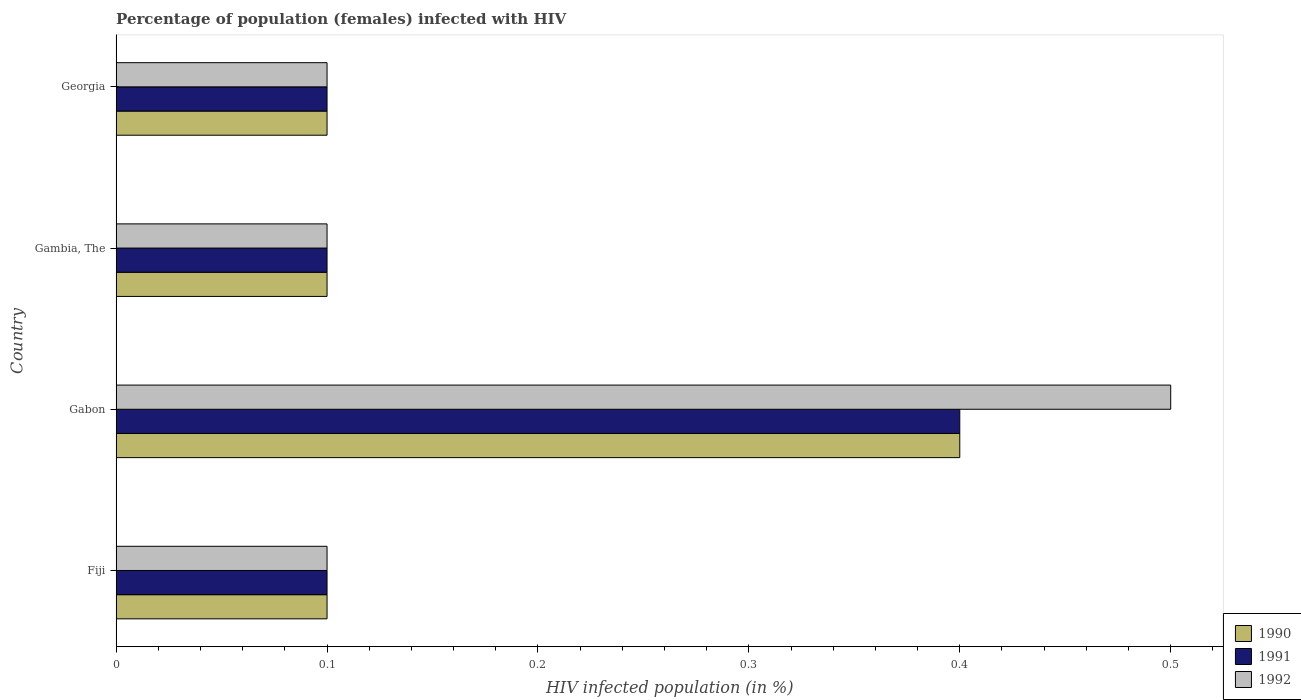How many different coloured bars are there?
Provide a succinct answer. 3. How many groups of bars are there?
Your answer should be compact. 4. Are the number of bars on each tick of the Y-axis equal?
Provide a short and direct response. Yes. How many bars are there on the 2nd tick from the top?
Provide a short and direct response. 3. How many bars are there on the 1st tick from the bottom?
Make the answer very short. 3. What is the label of the 3rd group of bars from the top?
Your answer should be very brief. Gabon. In how many cases, is the number of bars for a given country not equal to the number of legend labels?
Offer a very short reply. 0. What is the percentage of HIV infected female population in 1992 in Georgia?
Offer a terse response. 0.1. Across all countries, what is the maximum percentage of HIV infected female population in 1990?
Keep it short and to the point. 0.4. In which country was the percentage of HIV infected female population in 1990 maximum?
Provide a short and direct response. Gabon. In which country was the percentage of HIV infected female population in 1992 minimum?
Your answer should be very brief. Fiji. What is the total percentage of HIV infected female population in 1990 in the graph?
Provide a succinct answer. 0.7. What is the difference between the percentage of HIV infected female population in 1992 in Gambia, The and the percentage of HIV infected female population in 1990 in Georgia?
Provide a succinct answer. 0. What is the average percentage of HIV infected female population in 1990 per country?
Keep it short and to the point. 0.17. What is the difference between the percentage of HIV infected female population in 1992 and percentage of HIV infected female population in 1990 in Gabon?
Offer a terse response. 0.1. In how many countries, is the percentage of HIV infected female population in 1992 greater than 0.42000000000000004 %?
Provide a short and direct response. 1. What is the difference between the highest and the second highest percentage of HIV infected female population in 1990?
Keep it short and to the point. 0.3. In how many countries, is the percentage of HIV infected female population in 1990 greater than the average percentage of HIV infected female population in 1990 taken over all countries?
Provide a succinct answer. 1. Is the sum of the percentage of HIV infected female population in 1990 in Fiji and Gabon greater than the maximum percentage of HIV infected female population in 1992 across all countries?
Keep it short and to the point. No. What does the 1st bar from the bottom in Gambia, The represents?
Keep it short and to the point. 1990. Is it the case that in every country, the sum of the percentage of HIV infected female population in 1991 and percentage of HIV infected female population in 1992 is greater than the percentage of HIV infected female population in 1990?
Provide a short and direct response. Yes. Are all the bars in the graph horizontal?
Offer a very short reply. Yes. How many countries are there in the graph?
Offer a very short reply. 4. Does the graph contain any zero values?
Provide a succinct answer. No. How many legend labels are there?
Make the answer very short. 3. How are the legend labels stacked?
Your response must be concise. Vertical. What is the title of the graph?
Your response must be concise. Percentage of population (females) infected with HIV. What is the label or title of the X-axis?
Make the answer very short. HIV infected population (in %). What is the label or title of the Y-axis?
Give a very brief answer. Country. What is the HIV infected population (in %) in 1990 in Fiji?
Your answer should be compact. 0.1. What is the HIV infected population (in %) of 1990 in Gabon?
Your answer should be compact. 0.4. What is the HIV infected population (in %) in 1991 in Gambia, The?
Your answer should be compact. 0.1. What is the HIV infected population (in %) in 1991 in Georgia?
Offer a terse response. 0.1. What is the HIV infected population (in %) in 1992 in Georgia?
Your answer should be compact. 0.1. Across all countries, what is the maximum HIV infected population (in %) of 1992?
Offer a very short reply. 0.5. Across all countries, what is the minimum HIV infected population (in %) of 1990?
Your answer should be very brief. 0.1. Across all countries, what is the minimum HIV infected population (in %) in 1991?
Your response must be concise. 0.1. What is the total HIV infected population (in %) of 1990 in the graph?
Offer a very short reply. 0.7. What is the total HIV infected population (in %) in 1991 in the graph?
Your answer should be very brief. 0.7. What is the total HIV infected population (in %) in 1992 in the graph?
Give a very brief answer. 0.8. What is the difference between the HIV infected population (in %) of 1990 in Fiji and that in Gambia, The?
Your response must be concise. 0. What is the difference between the HIV infected population (in %) in 1990 in Fiji and that in Georgia?
Your answer should be compact. 0. What is the difference between the HIV infected population (in %) in 1990 in Gabon and that in Gambia, The?
Make the answer very short. 0.3. What is the difference between the HIV infected population (in %) of 1991 in Gabon and that in Gambia, The?
Keep it short and to the point. 0.3. What is the difference between the HIV infected population (in %) of 1992 in Gabon and that in Gambia, The?
Offer a terse response. 0.4. What is the difference between the HIV infected population (in %) of 1990 in Gambia, The and that in Georgia?
Offer a very short reply. 0. What is the difference between the HIV infected population (in %) in 1992 in Gambia, The and that in Georgia?
Offer a very short reply. 0. What is the difference between the HIV infected population (in %) in 1990 in Fiji and the HIV infected population (in %) in 1991 in Gabon?
Your answer should be compact. -0.3. What is the difference between the HIV infected population (in %) of 1990 in Fiji and the HIV infected population (in %) of 1991 in Gambia, The?
Offer a terse response. 0. What is the difference between the HIV infected population (in %) of 1990 in Fiji and the HIV infected population (in %) of 1991 in Georgia?
Your answer should be compact. 0. What is the difference between the HIV infected population (in %) of 1990 in Fiji and the HIV infected population (in %) of 1992 in Georgia?
Your answer should be very brief. 0. What is the difference between the HIV infected population (in %) of 1991 in Fiji and the HIV infected population (in %) of 1992 in Georgia?
Your answer should be compact. 0. What is the difference between the HIV infected population (in %) in 1990 in Gabon and the HIV infected population (in %) in 1991 in Gambia, The?
Provide a succinct answer. 0.3. What is the difference between the HIV infected population (in %) of 1990 in Gabon and the HIV infected population (in %) of 1992 in Gambia, The?
Your answer should be compact. 0.3. What is the difference between the HIV infected population (in %) of 1990 in Gabon and the HIV infected population (in %) of 1991 in Georgia?
Provide a short and direct response. 0.3. What is the difference between the HIV infected population (in %) of 1990 in Gabon and the HIV infected population (in %) of 1992 in Georgia?
Ensure brevity in your answer.  0.3. What is the difference between the HIV infected population (in %) of 1991 in Gabon and the HIV infected population (in %) of 1992 in Georgia?
Your response must be concise. 0.3. What is the difference between the HIV infected population (in %) of 1991 in Gambia, The and the HIV infected population (in %) of 1992 in Georgia?
Make the answer very short. 0. What is the average HIV infected population (in %) in 1990 per country?
Provide a succinct answer. 0.17. What is the average HIV infected population (in %) in 1991 per country?
Your response must be concise. 0.17. What is the average HIV infected population (in %) of 1992 per country?
Your answer should be very brief. 0.2. What is the difference between the HIV infected population (in %) of 1990 and HIV infected population (in %) of 1991 in Fiji?
Your answer should be compact. 0. What is the difference between the HIV infected population (in %) of 1991 and HIV infected population (in %) of 1992 in Fiji?
Your answer should be very brief. 0. What is the difference between the HIV infected population (in %) of 1990 and HIV infected population (in %) of 1991 in Gabon?
Your answer should be compact. 0. What is the difference between the HIV infected population (in %) in 1990 and HIV infected population (in %) in 1992 in Gabon?
Give a very brief answer. -0.1. What is the ratio of the HIV infected population (in %) of 1990 in Fiji to that in Gabon?
Offer a terse response. 0.25. What is the ratio of the HIV infected population (in %) of 1991 in Fiji to that in Gabon?
Offer a very short reply. 0.25. What is the ratio of the HIV infected population (in %) in 1992 in Fiji to that in Gabon?
Provide a succinct answer. 0.2. What is the ratio of the HIV infected population (in %) in 1990 in Fiji to that in Gambia, The?
Your response must be concise. 1. What is the ratio of the HIV infected population (in %) in 1991 in Fiji to that in Gambia, The?
Offer a terse response. 1. What is the ratio of the HIV infected population (in %) of 1992 in Fiji to that in Gambia, The?
Your answer should be compact. 1. What is the ratio of the HIV infected population (in %) of 1991 in Fiji to that in Georgia?
Offer a terse response. 1. What is the ratio of the HIV infected population (in %) of 1990 in Gabon to that in Gambia, The?
Your answer should be very brief. 4. What is the ratio of the HIV infected population (in %) in 1991 in Gabon to that in Gambia, The?
Your answer should be compact. 4. What is the ratio of the HIV infected population (in %) of 1992 in Gabon to that in Gambia, The?
Offer a terse response. 5. What is the difference between the highest and the second highest HIV infected population (in %) in 1990?
Make the answer very short. 0.3. What is the difference between the highest and the second highest HIV infected population (in %) of 1992?
Your answer should be very brief. 0.4. What is the difference between the highest and the lowest HIV infected population (in %) in 1990?
Ensure brevity in your answer.  0.3. What is the difference between the highest and the lowest HIV infected population (in %) of 1991?
Provide a short and direct response. 0.3. What is the difference between the highest and the lowest HIV infected population (in %) in 1992?
Make the answer very short. 0.4. 